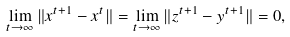<formula> <loc_0><loc_0><loc_500><loc_500>\lim _ { t \rightarrow \infty } \| x ^ { t + 1 } - x ^ { t } \| = \lim _ { t \rightarrow \infty } \| z ^ { t + 1 } - y ^ { t + 1 } \| = 0 ,</formula> 